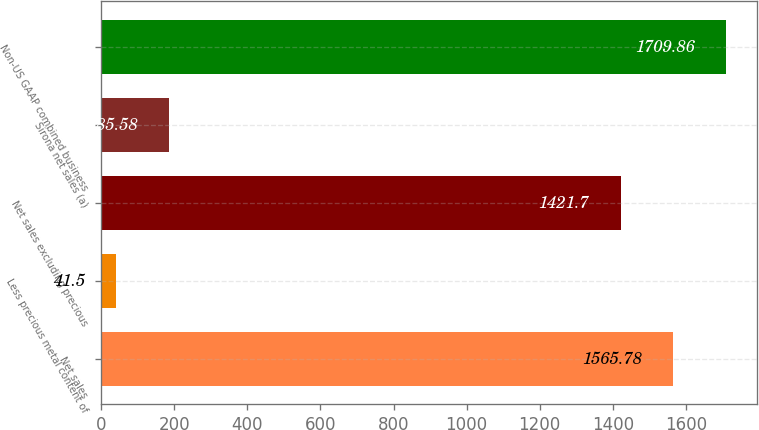<chart> <loc_0><loc_0><loc_500><loc_500><bar_chart><fcel>Net sales<fcel>Less precious metal content of<fcel>Net sales excluding precious<fcel>Sirona net sales (a)<fcel>Non-US GAAP combined business<nl><fcel>1565.78<fcel>41.5<fcel>1421.7<fcel>185.58<fcel>1709.86<nl></chart> 